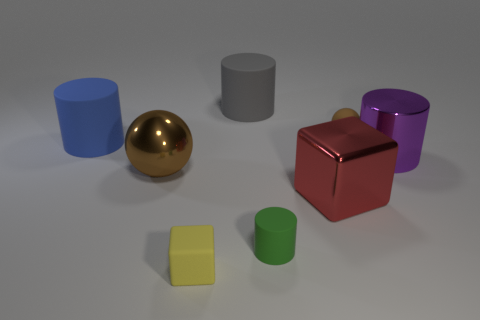Are there any other things of the same color as the tiny ball?
Your response must be concise. Yes. Is the large metallic ball the same color as the small ball?
Keep it short and to the point. Yes. What number of other shiny balls are the same color as the tiny ball?
Provide a short and direct response. 1. Do the ball left of the yellow matte cube and the rubber ball have the same color?
Offer a terse response. Yes. What shape is the brown thing that is on the right side of the small matte cube?
Keep it short and to the point. Sphere. What size is the matte ball that is the same color as the large metallic sphere?
Your response must be concise. Small. How big is the rubber thing that is behind the blue matte cylinder and on the left side of the big red metallic cube?
Make the answer very short. Large. There is a brown object that is in front of the purple shiny cylinder to the right of the big shiny thing that is to the left of the gray thing; what is its material?
Ensure brevity in your answer.  Metal. What material is the small ball that is the same color as the big ball?
Offer a very short reply. Rubber. There is a small thing that is behind the metal sphere; is its color the same as the ball that is left of the red shiny cube?
Provide a short and direct response. Yes. 